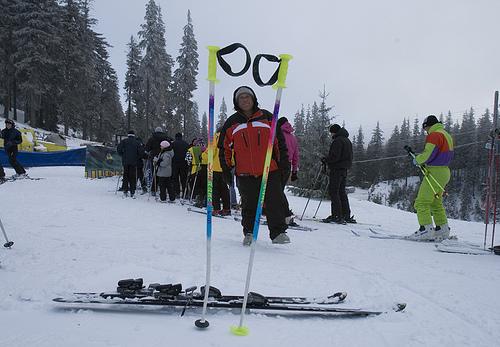What gender is the person framed by the two poles?
Be succinct. Male. What sport is happening?
Keep it brief. Skiing. What are the people doing?
Quick response, please. Skiing. Are these skier's competing?
Short answer required. No. Is anyone wearing a pink coat?
Quick response, please. Yes. 